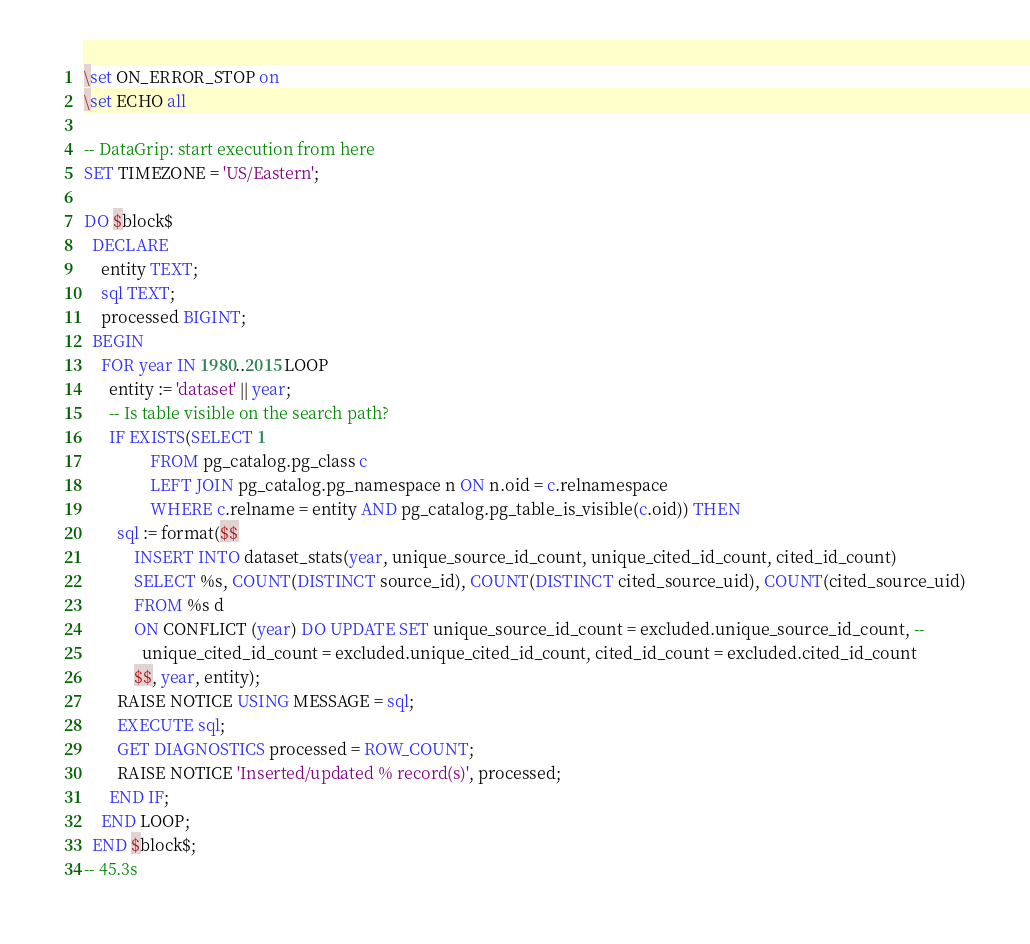Convert code to text. <code><loc_0><loc_0><loc_500><loc_500><_SQL_>\set ON_ERROR_STOP on
\set ECHO all

-- DataGrip: start execution from here
SET TIMEZONE = 'US/Eastern';

DO $block$
  DECLARE
    entity TEXT;
    sql TEXT;
    processed BIGINT;
  BEGIN
    FOR year IN 1980..2015 LOOP
      entity := 'dataset' || year;
      -- Is table visible on the search path?
      IF EXISTS(SELECT 1
                FROM pg_catalog.pg_class c
                LEFT JOIN pg_catalog.pg_namespace n ON n.oid = c.relnamespace
                WHERE c.relname = entity AND pg_catalog.pg_table_is_visible(c.oid)) THEN
        sql := format($$
            INSERT INTO dataset_stats(year, unique_source_id_count, unique_cited_id_count, cited_id_count)
            SELECT %s, COUNT(DISTINCT source_id), COUNT(DISTINCT cited_source_uid), COUNT(cited_source_uid)
            FROM %s d
            ON CONFLICT (year) DO UPDATE SET unique_source_id_count = excluded.unique_source_id_count, --
              unique_cited_id_count = excluded.unique_cited_id_count, cited_id_count = excluded.cited_id_count
            $$, year, entity);
        RAISE NOTICE USING MESSAGE = sql;
        EXECUTE sql;
        GET DIAGNOSTICS processed = ROW_COUNT;
        RAISE NOTICE 'Inserted/updated % record(s)', processed;
      END IF;
    END LOOP;
  END $block$;
-- 45.3s</code> 